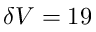Convert formula to latex. <formula><loc_0><loc_0><loc_500><loc_500>\delta V = 1 9</formula> 